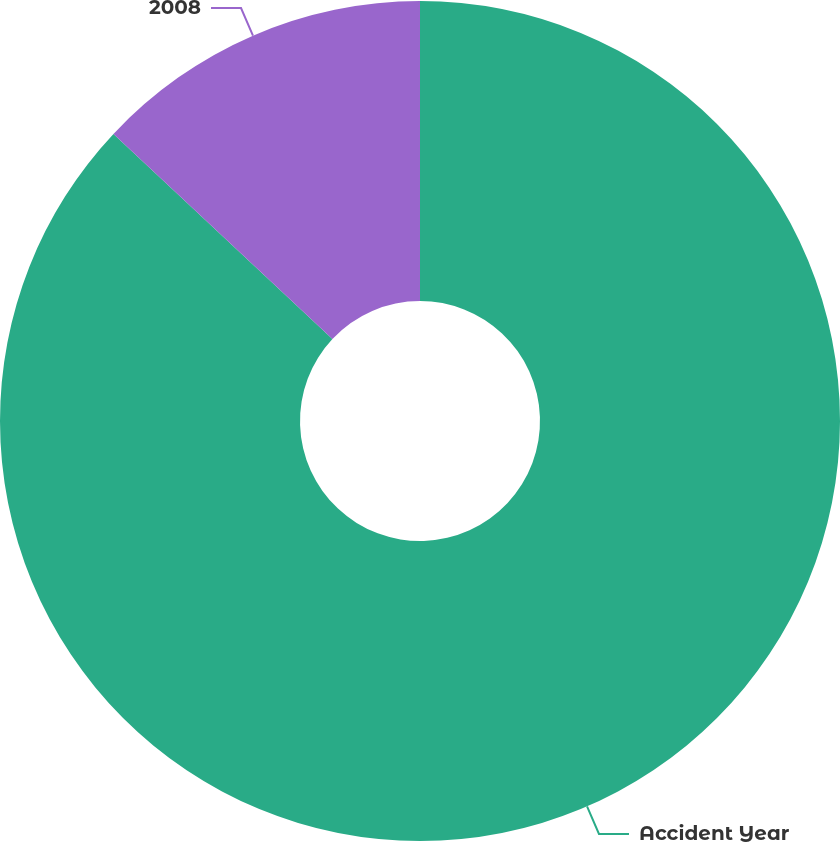<chart> <loc_0><loc_0><loc_500><loc_500><pie_chart><fcel>Accident Year<fcel>2008<nl><fcel>86.98%<fcel>13.02%<nl></chart> 